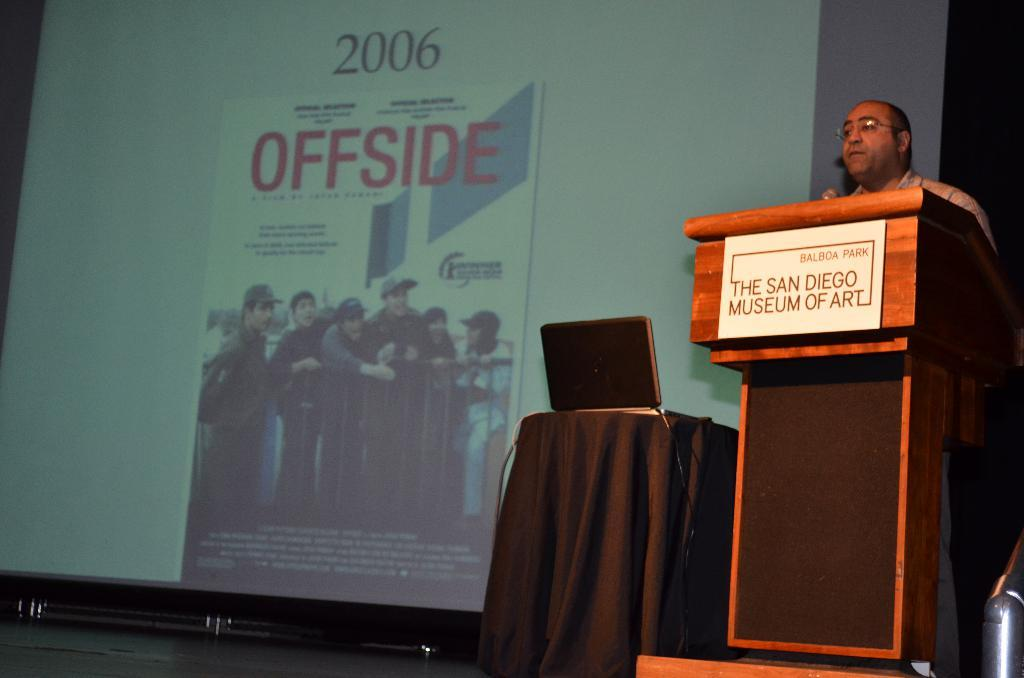Who is present in the image? There is a person in the image. What is the person standing in front of? The person is standing in front of a desk. What electronic device is on the desk? There is a laptop on the table. What is the purpose of the projector screen in the image? The projector screen is likely used for presentations or displaying visual information. What type of street is visible through the window in the image? There is no window or street visible in the image; it only shows a person standing in front of a desk with a laptop and projector screen. 